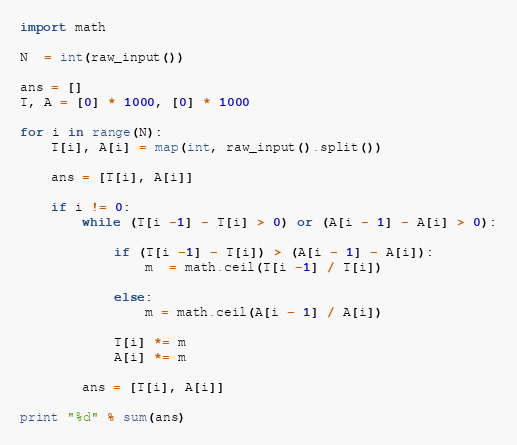Convert code to text. <code><loc_0><loc_0><loc_500><loc_500><_Python_>import math

N  = int(raw_input())

ans = []
T, A = [0] * 1000, [0] * 1000

for i in range(N):
    T[i], A[i] = map(int, raw_input().split())

    ans = [T[i], A[i]]

    if i != 0:
        while (T[i -1] - T[i] > 0) or (A[i - 1] - A[i] > 0):

            if (T[i -1] - T[i]) > (A[i - 1] - A[i]):
                m  = math.ceil(T[i -1] / T[i]) 

            else:
                m = math.ceil(A[i - 1] / A[i])

            T[i] *= m
            A[i] *= m

        ans = [T[i], A[i]]

print "%d" % sum(ans)</code> 